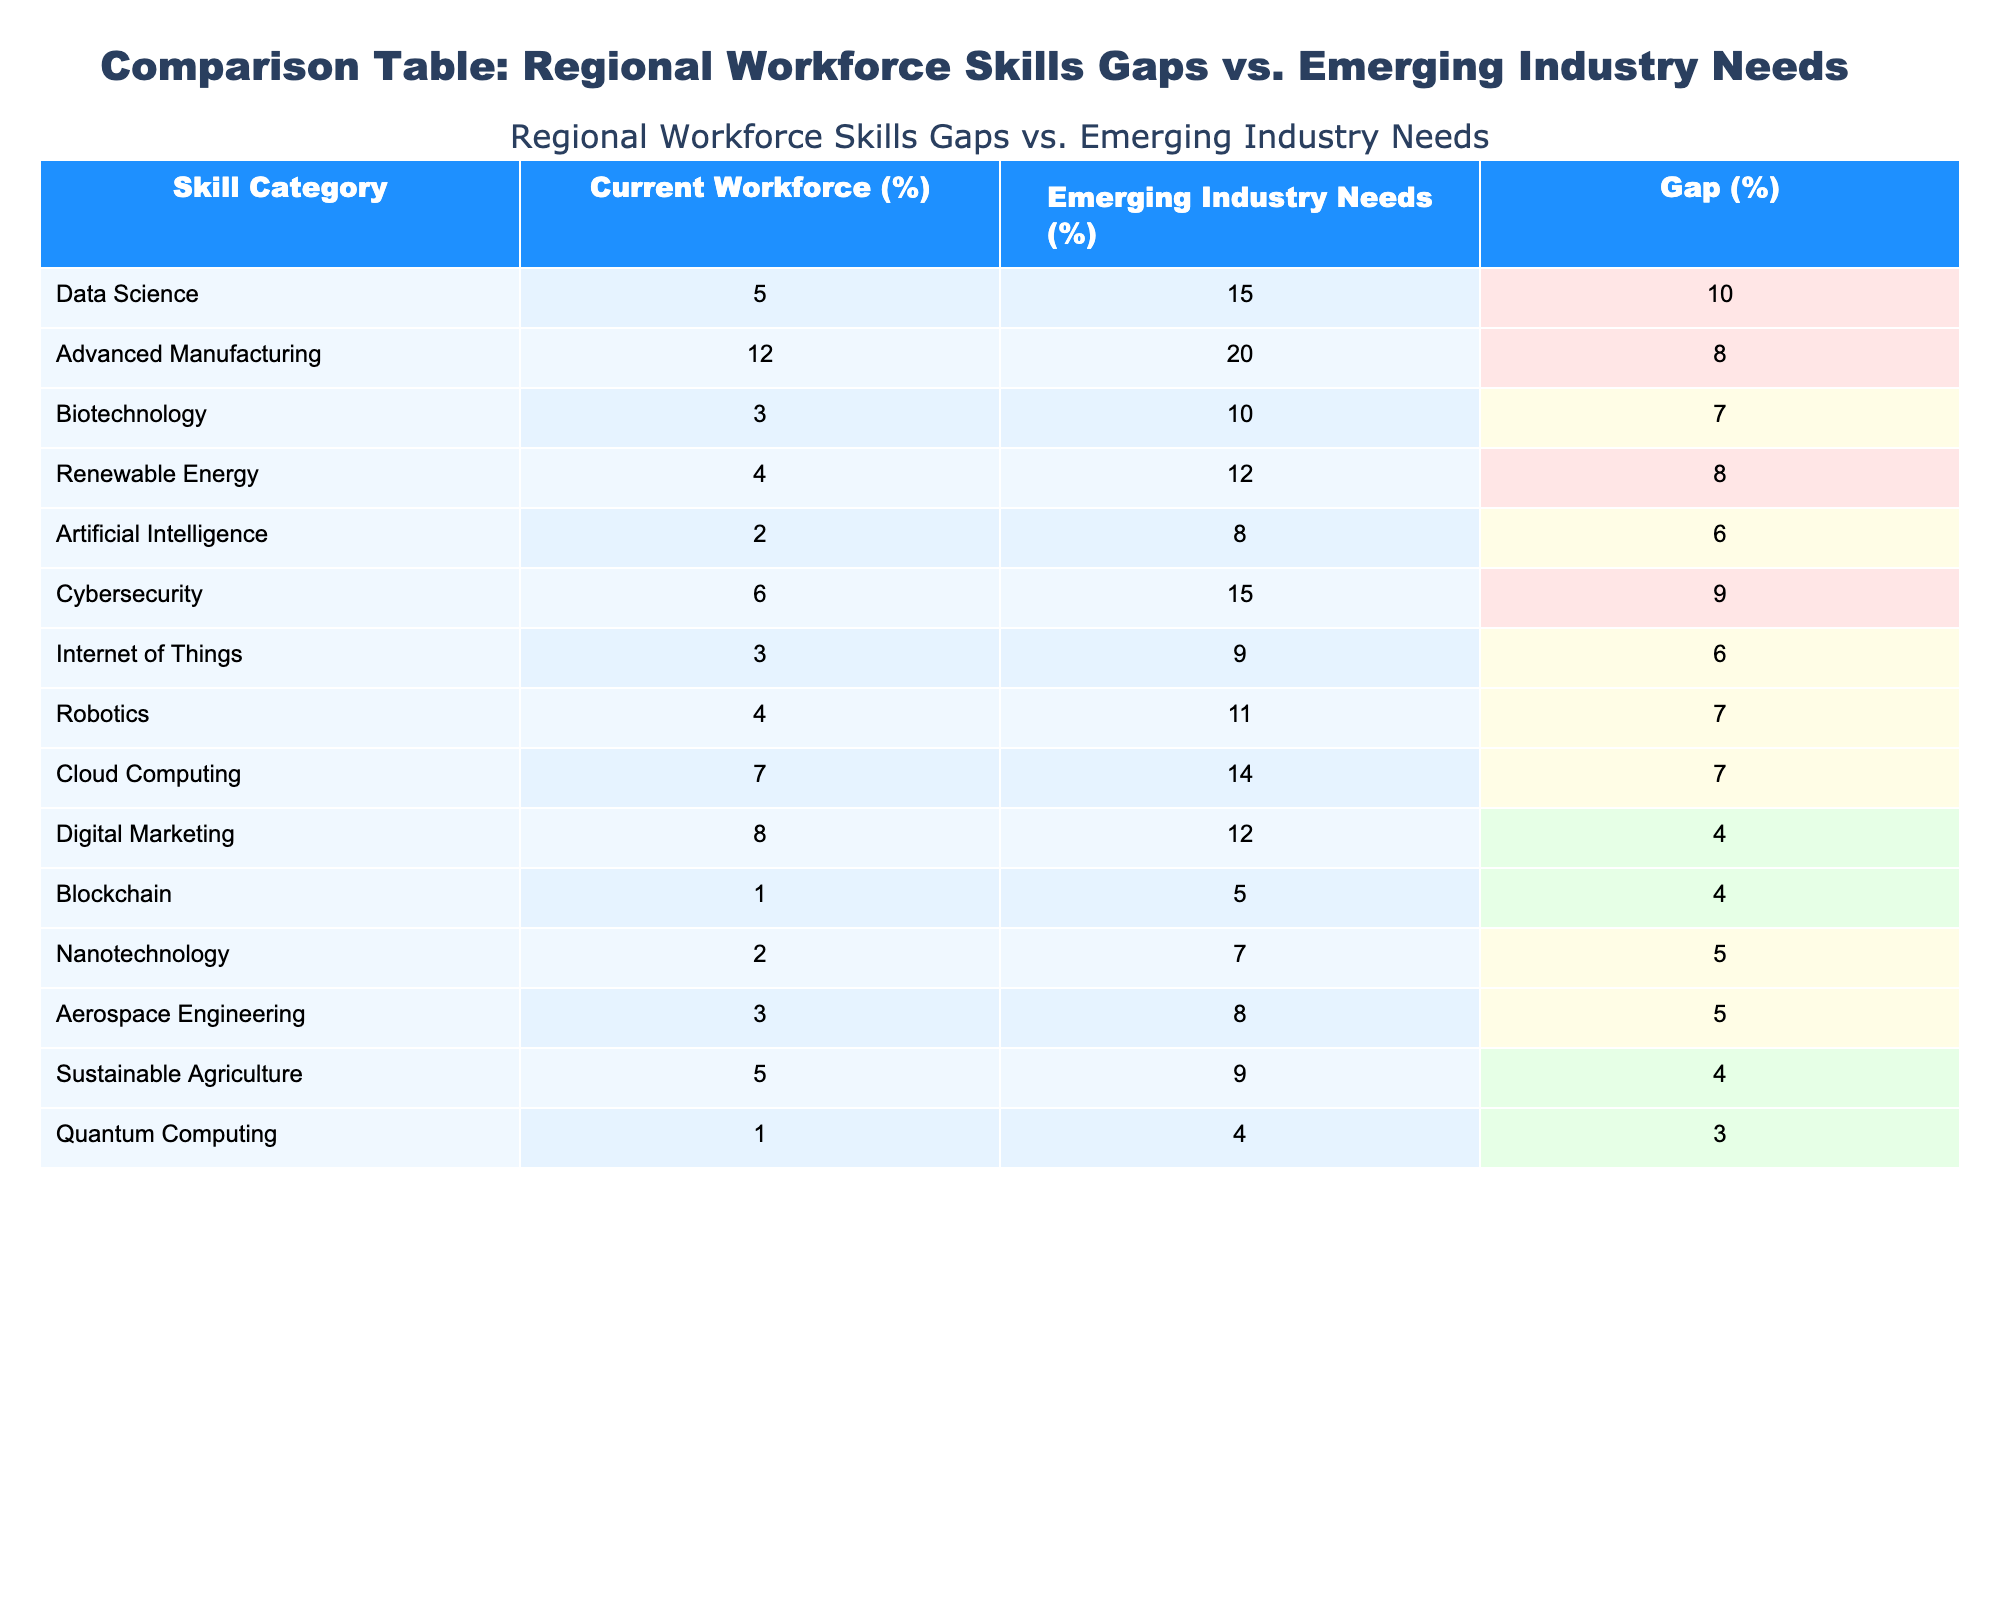What is the skill category with the largest gap between current workforce and emerging industry needs? The gap is the difference between the current workforce percentage and the emerging industry needs percentage for each skill category. By checking the "Gap (%)" column, the largest gap is seen in "Data Science" with a value of 10%.
Answer: Data Science Which skill category has the highest percentage of current workforce? By examining the "Current Workforce (%)" column, the highest percentage recorded is 12% for "Advanced Manufacturing."
Answer: Advanced Manufacturing Is the current workforce percentage in Cybersecurity greater than that in Artificial Intelligence? Looking at the "Current Workforce (%)" for Cybersecurity, which is 6%, and for Artificial Intelligence, which is 2%, we find that Cybersecurity's percentage is indeed greater.
Answer: Yes What is the total gap across all skill categories? We sum the gaps from the "Gap (%)" column: (10 + 8 + 7 + 8 + 6 + 9 + 6 + 7 + 7 + 4 + 4 + 5 + 5 + 4 + 3) = 81%. Therefore, the total gap is 81%.
Answer: 81 Is there a skill category where the current workforce matches the emerging industry needs? We look for any rows in which the "Current Workforce (%)" is equal to the "Emerging Industry Needs (%)". Upon review, there are no skill categories in which these two percentages are the same.
Answer: No Which two skill categories have the smallest gap between current workforce and emerging industry needs? The smallest gaps can be seen in "Digital Marketing" and "Quantum Computing," where the gaps are 4% and 3%, respectively. Comparing these two, "Quantum Computing" has the smallest gap of 3%.
Answer: Quantum Computing and Digital Marketing What percentage is the current workforce in Renewable Energy compared to its emerging needs? The current workforce percentage in Renewable Energy is 4%, while the emerging needs percentage is 12%. To compare these, we can express them as a ratio or percentage, confirming that there is a difference of 8%.
Answer: Current: 4%, Emerging: 12% How does the current workforce in Robotics compare to that in Cloud Computing? By examining both skill categories, Robotics has a current workforce of 4%, while Cloud Computing has 7%. Thus, Cloud Computing has a higher current workforce by 3%.
Answer: Cloud Computing is higher by 3% What is the average gap for all skill categories combined? To calculate the average gap, we add all gap percentages and divide by the total number of skill categories. The total is 81%, and there are 15 categories, making the average gap 81% / 15 = 5.4%.
Answer: 5.4% 